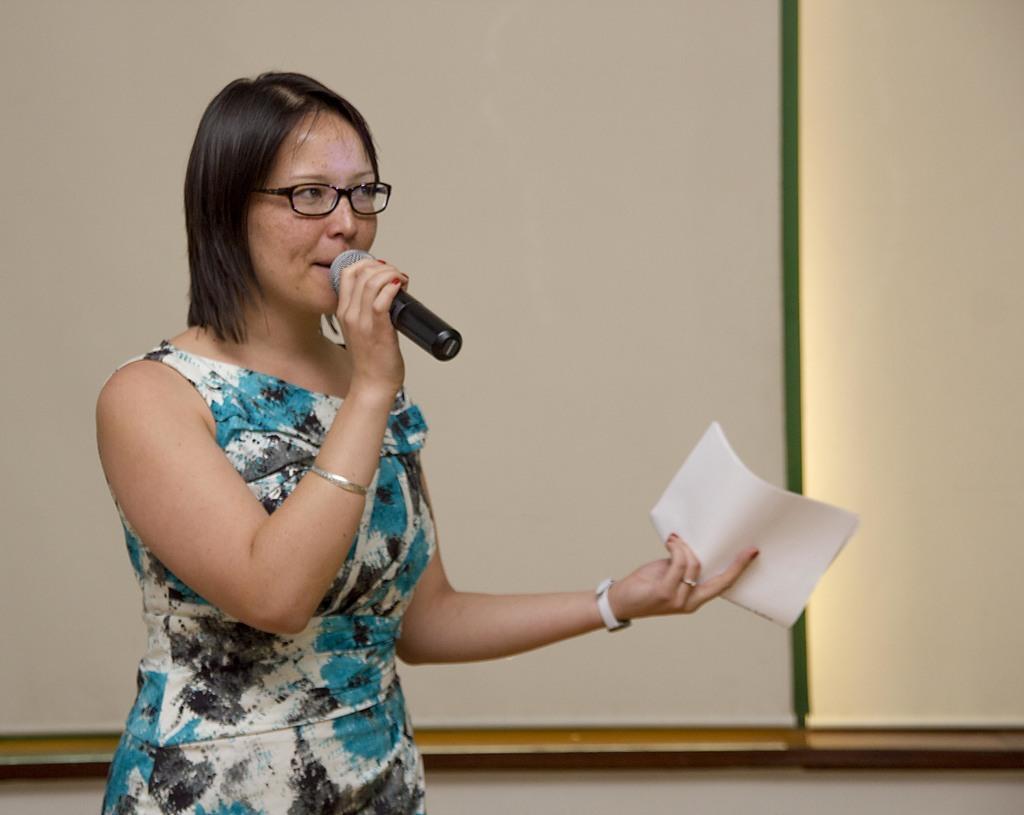In one or two sentences, can you explain what this image depicts? In this image is a woman holding a mic in one hand and papers in another hand is delivering a speech, behind the woman there is a screen. 